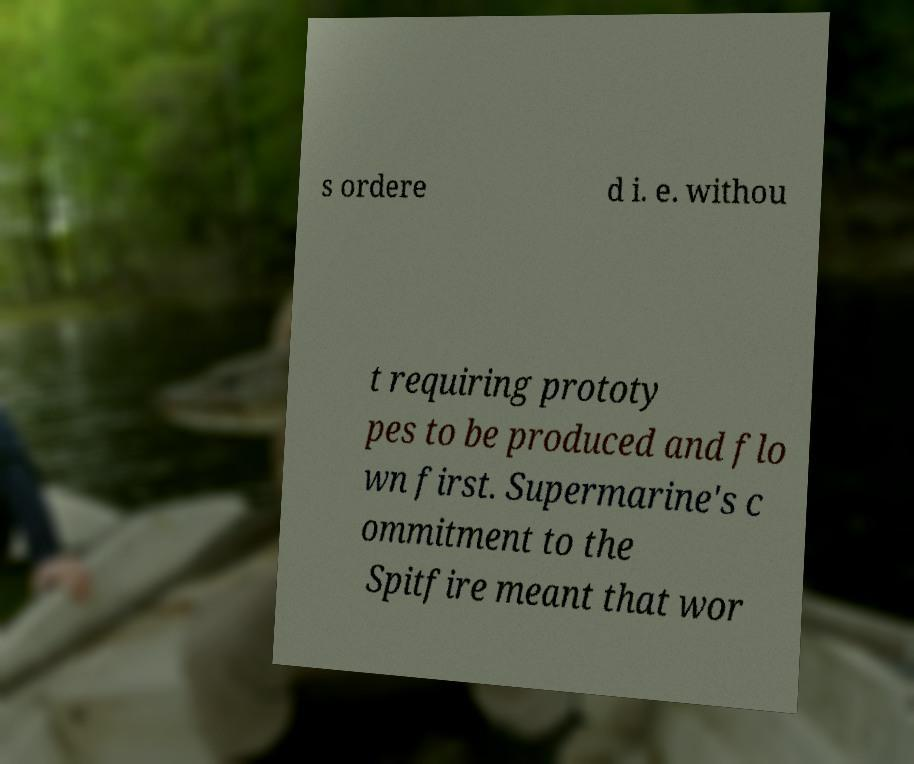What messages or text are displayed in this image? I need them in a readable, typed format. s ordere d i. e. withou t requiring prototy pes to be produced and flo wn first. Supermarine's c ommitment to the Spitfire meant that wor 